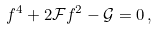Convert formula to latex. <formula><loc_0><loc_0><loc_500><loc_500>f ^ { 4 } + 2 \mathcal { F } f ^ { 2 } - \mathcal { G } = 0 \, ,</formula> 